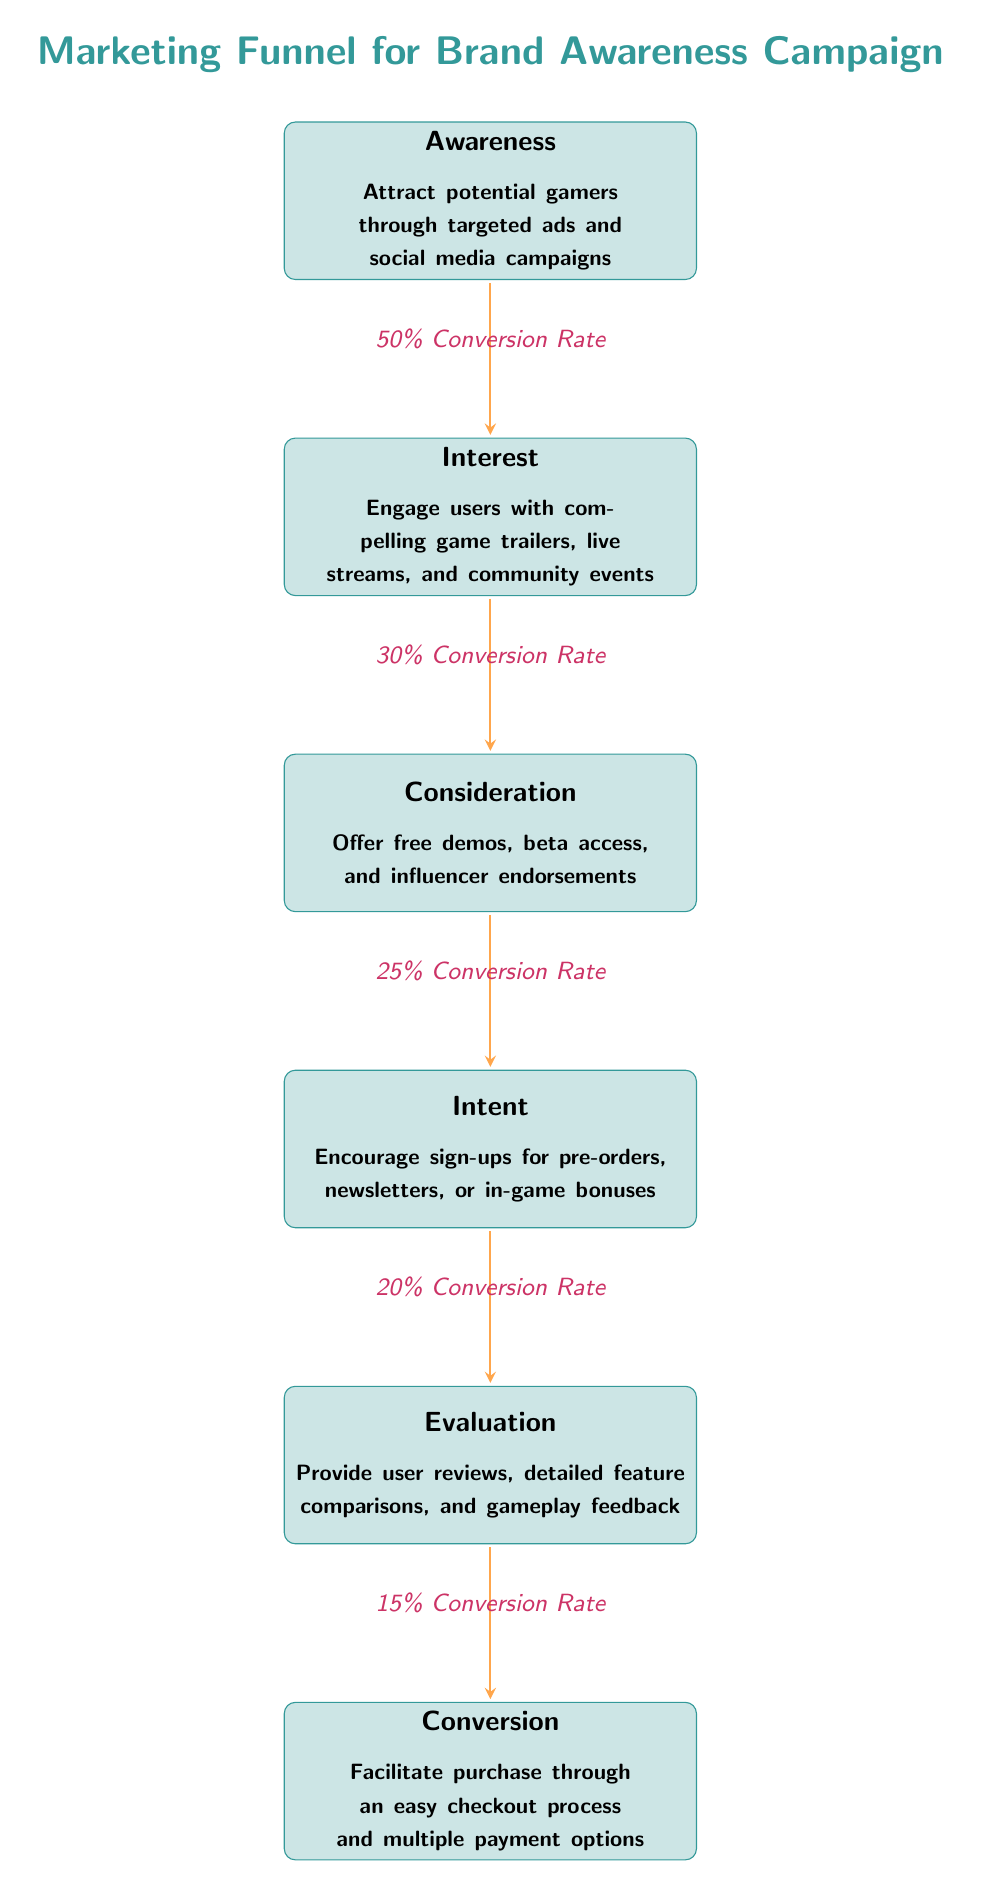What is the first step in the marketing funnel? The first step is "Awareness," which focuses on attracting potential gamers through targeted ads and social media campaigns.
Answer: Awareness What is the conversion rate between "Consideration" and "Intent"? The conversion rate between "Consideration" and "Intent" is 25%, as indicated in the diagram connecting these two nodes.
Answer: 25% How many nodes are in the diagram? There are a total of six nodes in the marketing funnel: Awareness, Interest, Consideration, Intent, Evaluation, and Conversion.
Answer: 6 What is the conversion rate from "Interest" to "Consideration"? The conversion rate from "Interest" to "Consideration" is 30%, which is displayed as the label on the arrow connecting the two nodes.
Answer: 30% Which step has the lowest conversion rate? The step with the lowest conversion rate is "Conversion," which shows a conversion rate of 15%.
Answer: Conversion What percentage of users proceeding from "Awareness" to "Interest" is expected? The expected percentage of users proceeding from "Awareness" to "Interest" is 50%, as noted along the arrow connecting these steps.
Answer: 50% What node follows "Evaluation"? The node that follows "Evaluation" is "Conversion," which represents the final step in the marketing funnel.
Answer: Conversion What is the flow direction of the diagram? The flow direction of the diagram is top to bottom, as each step leads to the next one below it in the funnel.
Answer: Top to bottom What do "Free demos" and "Influencer endorsements" fall under in this diagram? "Free demos" and "Influencer endorsements" are part of the "Consideration" node in the funnel.
Answer: Consideration 